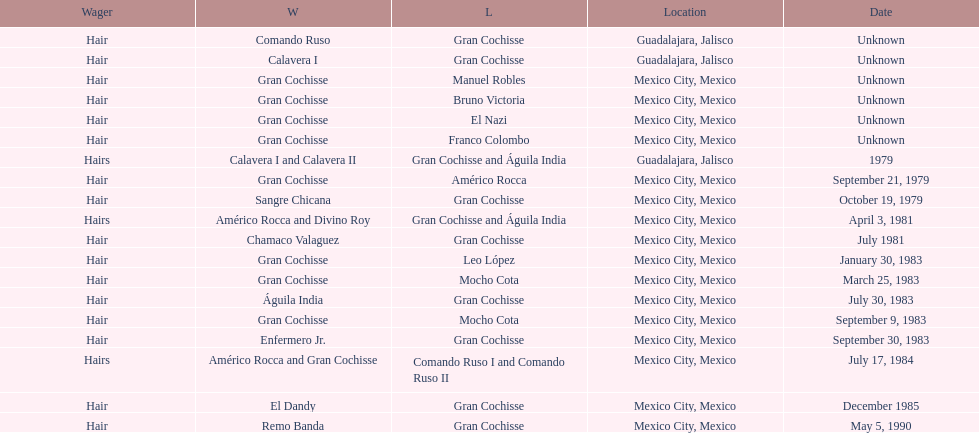How many times has the wager been hair? 16. 